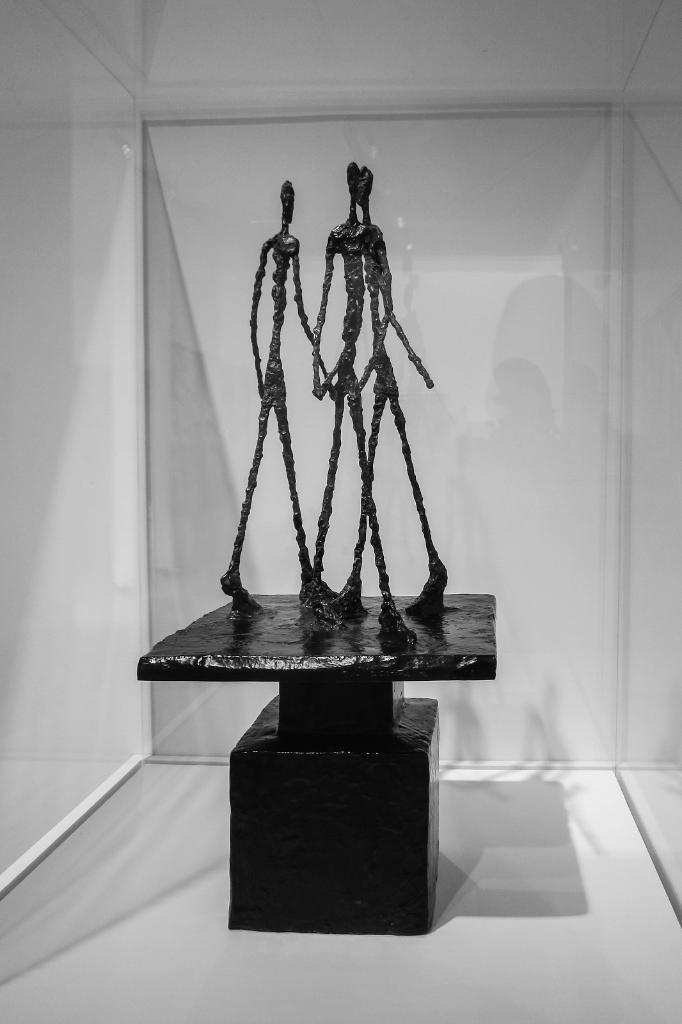What can be seen on the surface in the image? There are statues on the surface in the image. What material is visible in the image? Glass is visible in the image. What color is the background of the image? The background of the image is white. Where is the toy hidden in the image? There is no toy present in the image. What type of pocket can be seen in the image? There are no pockets visible in the image. 